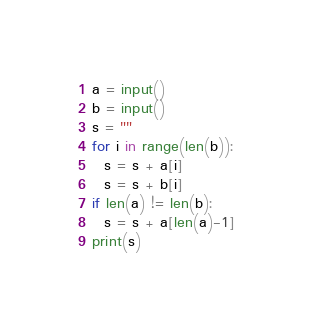Convert code to text. <code><loc_0><loc_0><loc_500><loc_500><_Python_>a = input()
b = input()
s = ""
for i in range(len(b)):
  s = s + a[i]
  s = s + b[i]
if len(a) != len(b):
  s = s + a[len(a)-1]
print(s)</code> 